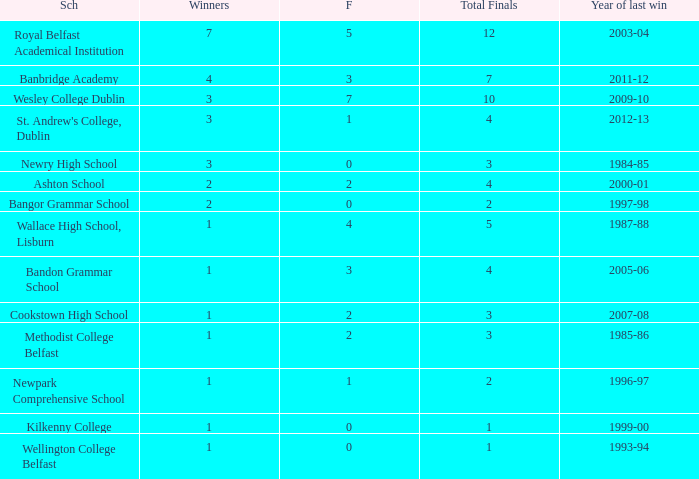What are the names that had a finalist score of 2? Ashton School, Cookstown High School, Methodist College Belfast. 